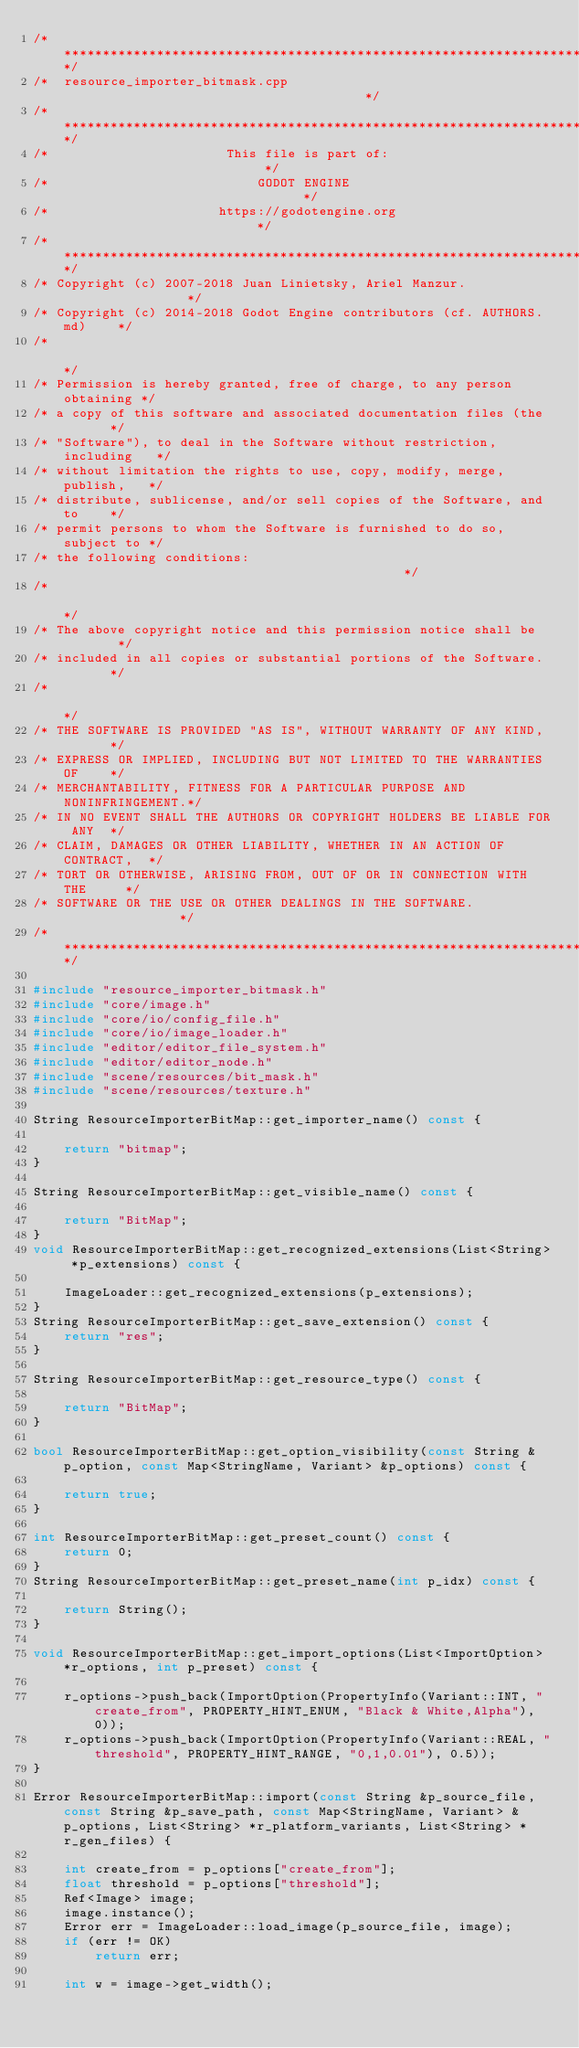<code> <loc_0><loc_0><loc_500><loc_500><_C++_>/*************************************************************************/
/*  resource_importer_bitmask.cpp                                        */
/*************************************************************************/
/*                       This file is part of:                           */
/*                           GODOT ENGINE                                */
/*                      https://godotengine.org                          */
/*************************************************************************/
/* Copyright (c) 2007-2018 Juan Linietsky, Ariel Manzur.                 */
/* Copyright (c) 2014-2018 Godot Engine contributors (cf. AUTHORS.md)    */
/*                                                                       */
/* Permission is hereby granted, free of charge, to any person obtaining */
/* a copy of this software and associated documentation files (the       */
/* "Software"), to deal in the Software without restriction, including   */
/* without limitation the rights to use, copy, modify, merge, publish,   */
/* distribute, sublicense, and/or sell copies of the Software, and to    */
/* permit persons to whom the Software is furnished to do so, subject to */
/* the following conditions:                                             */
/*                                                                       */
/* The above copyright notice and this permission notice shall be        */
/* included in all copies or substantial portions of the Software.       */
/*                                                                       */
/* THE SOFTWARE IS PROVIDED "AS IS", WITHOUT WARRANTY OF ANY KIND,       */
/* EXPRESS OR IMPLIED, INCLUDING BUT NOT LIMITED TO THE WARRANTIES OF    */
/* MERCHANTABILITY, FITNESS FOR A PARTICULAR PURPOSE AND NONINFRINGEMENT.*/
/* IN NO EVENT SHALL THE AUTHORS OR COPYRIGHT HOLDERS BE LIABLE FOR ANY  */
/* CLAIM, DAMAGES OR OTHER LIABILITY, WHETHER IN AN ACTION OF CONTRACT,  */
/* TORT OR OTHERWISE, ARISING FROM, OUT OF OR IN CONNECTION WITH THE     */
/* SOFTWARE OR THE USE OR OTHER DEALINGS IN THE SOFTWARE.                */
/*************************************************************************/

#include "resource_importer_bitmask.h"
#include "core/image.h"
#include "core/io/config_file.h"
#include "core/io/image_loader.h"
#include "editor/editor_file_system.h"
#include "editor/editor_node.h"
#include "scene/resources/bit_mask.h"
#include "scene/resources/texture.h"

String ResourceImporterBitMap::get_importer_name() const {

	return "bitmap";
}

String ResourceImporterBitMap::get_visible_name() const {

	return "BitMap";
}
void ResourceImporterBitMap::get_recognized_extensions(List<String> *p_extensions) const {

	ImageLoader::get_recognized_extensions(p_extensions);
}
String ResourceImporterBitMap::get_save_extension() const {
	return "res";
}

String ResourceImporterBitMap::get_resource_type() const {

	return "BitMap";
}

bool ResourceImporterBitMap::get_option_visibility(const String &p_option, const Map<StringName, Variant> &p_options) const {

	return true;
}

int ResourceImporterBitMap::get_preset_count() const {
	return 0;
}
String ResourceImporterBitMap::get_preset_name(int p_idx) const {

	return String();
}

void ResourceImporterBitMap::get_import_options(List<ImportOption> *r_options, int p_preset) const {

	r_options->push_back(ImportOption(PropertyInfo(Variant::INT, "create_from", PROPERTY_HINT_ENUM, "Black & White,Alpha"), 0));
	r_options->push_back(ImportOption(PropertyInfo(Variant::REAL, "threshold", PROPERTY_HINT_RANGE, "0,1,0.01"), 0.5));
}

Error ResourceImporterBitMap::import(const String &p_source_file, const String &p_save_path, const Map<StringName, Variant> &p_options, List<String> *r_platform_variants, List<String> *r_gen_files) {

	int create_from = p_options["create_from"];
	float threshold = p_options["threshold"];
	Ref<Image> image;
	image.instance();
	Error err = ImageLoader::load_image(p_source_file, image);
	if (err != OK)
		return err;

	int w = image->get_width();</code> 